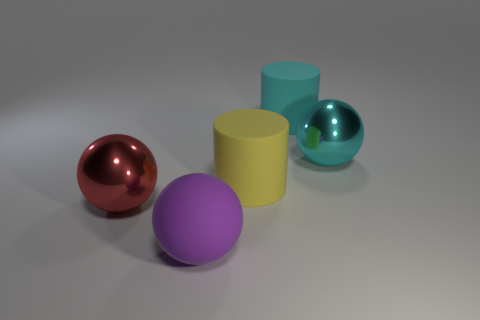There is a metal thing that is right of the thing that is in front of the big thing left of the large matte sphere; what is its shape?
Your response must be concise. Sphere. What is the shape of the big matte thing that is in front of the big cyan rubber cylinder and behind the purple sphere?
Provide a short and direct response. Cylinder. There is a big shiny sphere right of the large sphere in front of the red object left of the large purple thing; what color is it?
Make the answer very short. Cyan. What color is the rubber object that is the same shape as the cyan metallic object?
Offer a very short reply. Purple. Are there an equal number of matte things behind the large yellow matte cylinder and purple matte balls?
Your response must be concise. Yes. What number of blocks are either red metal objects or yellow objects?
Provide a succinct answer. 0. There is another large cylinder that is made of the same material as the big cyan cylinder; what color is it?
Your response must be concise. Yellow. Does the large purple thing have the same material as the ball that is to the right of the purple matte sphere?
Keep it short and to the point. No. What number of things are big rubber cylinders or blue metal spheres?
Give a very brief answer. 2. Is there a tiny metal object that has the same shape as the yellow rubber thing?
Ensure brevity in your answer.  No. 